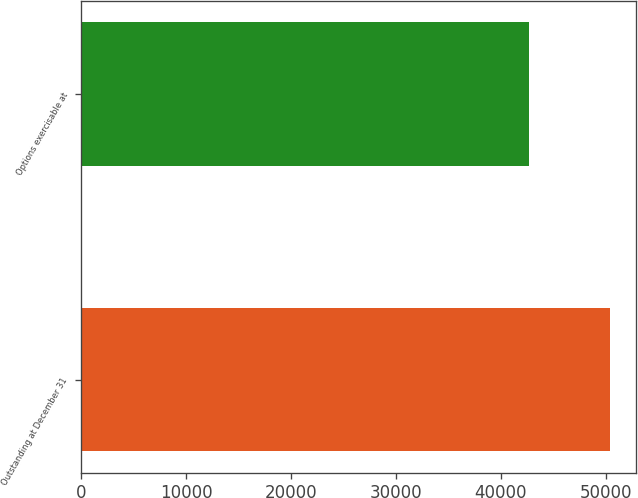<chart> <loc_0><loc_0><loc_500><loc_500><bar_chart><fcel>Outstanding at December 31<fcel>Options exercisable at<nl><fcel>50412<fcel>42674<nl></chart> 